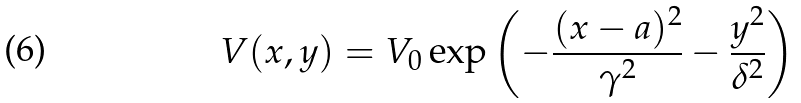Convert formula to latex. <formula><loc_0><loc_0><loc_500><loc_500>V ( x , y ) = V _ { 0 } \exp \left ( - \frac { ( x - a ) ^ { 2 } } { \gamma ^ { 2 } } - \frac { y ^ { 2 } } { \delta ^ { 2 } } \right )</formula> 